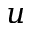<formula> <loc_0><loc_0><loc_500><loc_500>u</formula> 